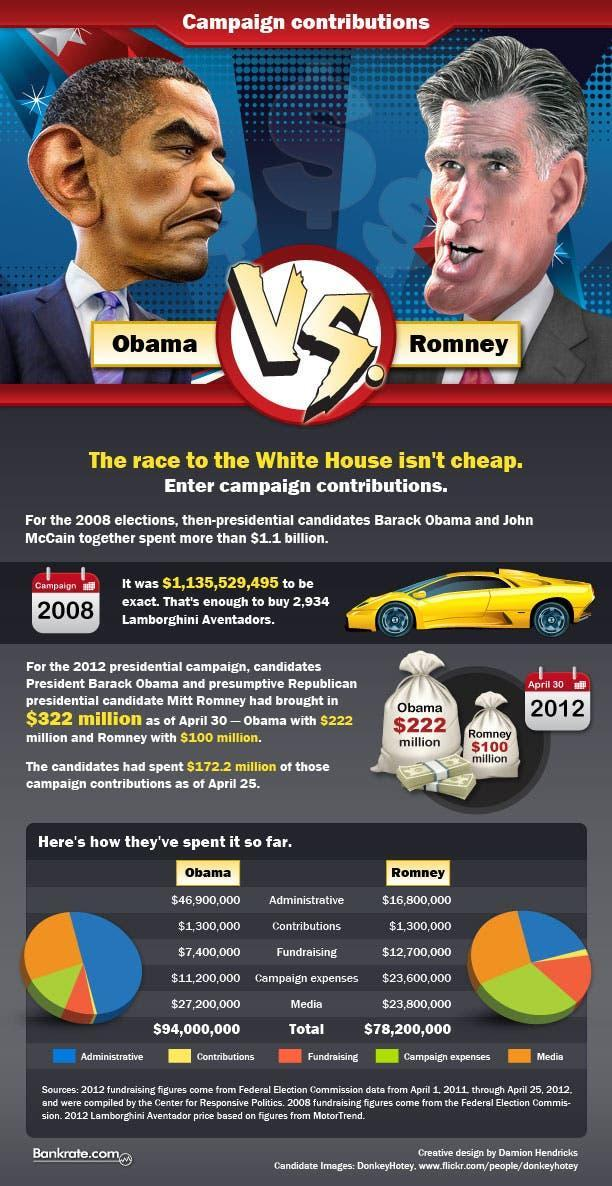To which factor, Obama gave the least preference during the presidential election campaign?
Answer the question with a short phrase. Contributions Who gave more preference to Fund Raising? Mitt Romney What is the color-code given to "Media"- green, yellow, orange, pink? orange What is the color-code given to "Administrative"- red, green, blue, orange? blue What is the color-code given to "Contributions"- green, yellow, blue, red? yellow What is the color-code given to "Fund Raising"- green, red, blue, orange? red What is the total expenditure in dollars spent by Obama and Romney took together for election? 17,22,00,000 To which factor, Romney gave a second highest preference during the presidential election campaign? Campaign expenses To which factor did Obama and Romney give equal importance? Contributions To which factor, Obama gave a second highest preference during the presidential election campaign? Media 